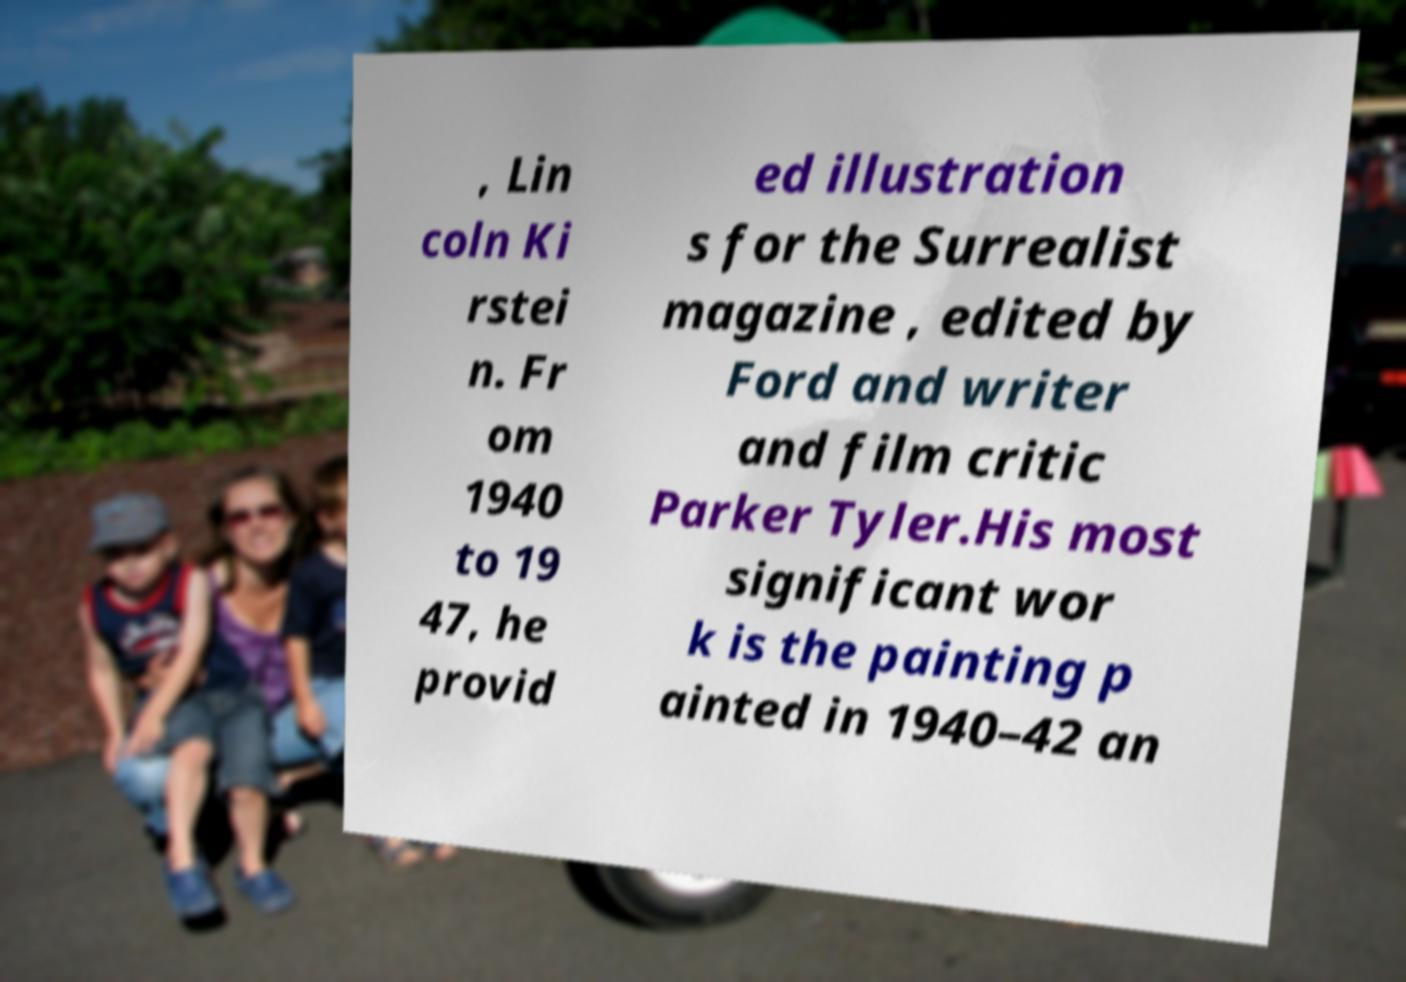What messages or text are displayed in this image? I need them in a readable, typed format. , Lin coln Ki rstei n. Fr om 1940 to 19 47, he provid ed illustration s for the Surrealist magazine , edited by Ford and writer and film critic Parker Tyler.His most significant wor k is the painting p ainted in 1940–42 an 